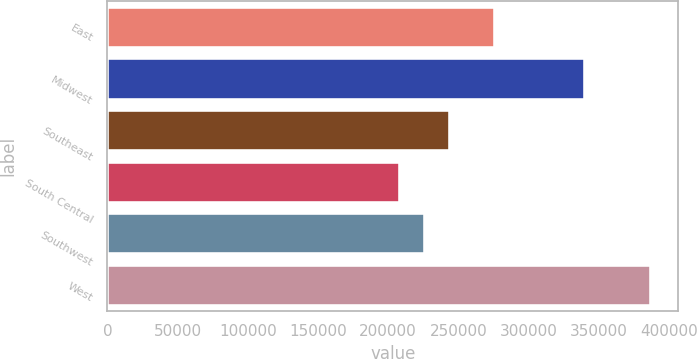<chart> <loc_0><loc_0><loc_500><loc_500><bar_chart><fcel>East<fcel>Midwest<fcel>Southeast<fcel>South Central<fcel>Southwest<fcel>West<nl><fcel>275800<fcel>340000<fcel>244280<fcel>208500<fcel>226390<fcel>387400<nl></chart> 